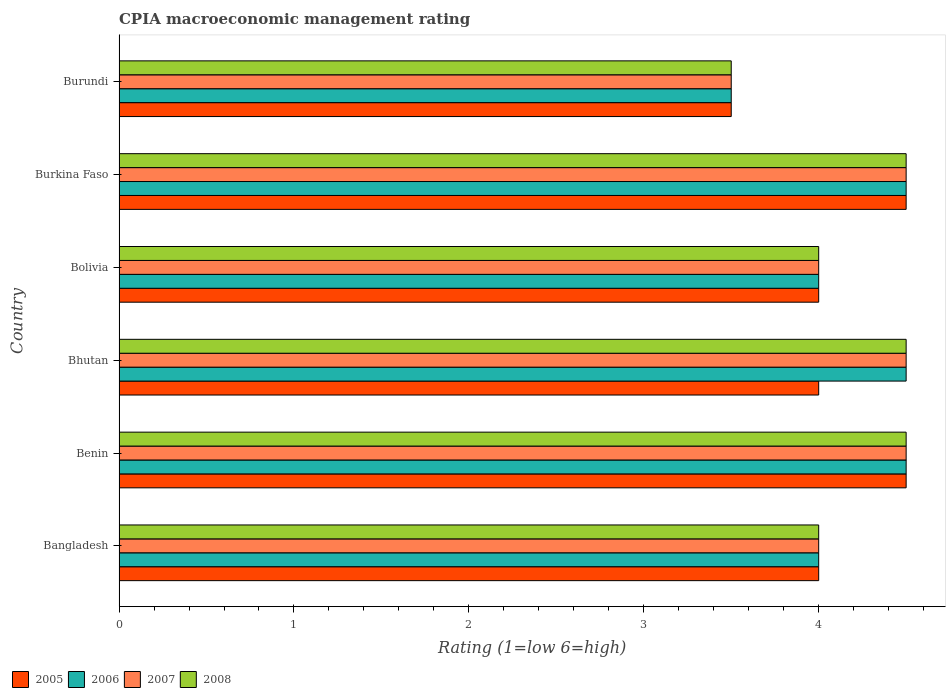How many different coloured bars are there?
Your answer should be very brief. 4. Are the number of bars per tick equal to the number of legend labels?
Keep it short and to the point. Yes. How many bars are there on the 2nd tick from the bottom?
Ensure brevity in your answer.  4. What is the label of the 4th group of bars from the top?
Your response must be concise. Bhutan. Across all countries, what is the minimum CPIA rating in 2006?
Offer a terse response. 3.5. In which country was the CPIA rating in 2005 maximum?
Your answer should be very brief. Benin. In which country was the CPIA rating in 2005 minimum?
Your answer should be very brief. Burundi. What is the difference between the CPIA rating in 2007 in Bangladesh and that in Burundi?
Make the answer very short. 0.5. What is the difference between the CPIA rating in 2007 in Bhutan and the CPIA rating in 2006 in Benin?
Offer a terse response. 0. What is the average CPIA rating in 2006 per country?
Keep it short and to the point. 4.17. In how many countries, is the CPIA rating in 2008 greater than 4 ?
Offer a very short reply. 3. What is the ratio of the CPIA rating in 2006 in Bolivia to that in Burkina Faso?
Your answer should be very brief. 0.89. Is the CPIA rating in 2005 in Bangladesh less than that in Burkina Faso?
Make the answer very short. Yes. What is the difference between the highest and the second highest CPIA rating in 2007?
Offer a terse response. 0. In how many countries, is the CPIA rating in 2006 greater than the average CPIA rating in 2006 taken over all countries?
Make the answer very short. 3. Is it the case that in every country, the sum of the CPIA rating in 2008 and CPIA rating in 2005 is greater than the sum of CPIA rating in 2006 and CPIA rating in 2007?
Keep it short and to the point. No. What does the 4th bar from the bottom in Bangladesh represents?
Provide a succinct answer. 2008. How many bars are there?
Keep it short and to the point. 24. What is the difference between two consecutive major ticks on the X-axis?
Make the answer very short. 1. Does the graph contain grids?
Offer a terse response. No. How are the legend labels stacked?
Your answer should be very brief. Horizontal. What is the title of the graph?
Make the answer very short. CPIA macroeconomic management rating. What is the Rating (1=low 6=high) of 2005 in Bangladesh?
Your response must be concise. 4. What is the Rating (1=low 6=high) in 2006 in Bangladesh?
Offer a terse response. 4. What is the Rating (1=low 6=high) in 2007 in Bangladesh?
Provide a short and direct response. 4. What is the Rating (1=low 6=high) in 2008 in Bangladesh?
Your answer should be very brief. 4. What is the Rating (1=low 6=high) in 2005 in Benin?
Make the answer very short. 4.5. What is the Rating (1=low 6=high) in 2007 in Benin?
Your answer should be very brief. 4.5. What is the Rating (1=low 6=high) of 2008 in Benin?
Provide a short and direct response. 4.5. What is the Rating (1=low 6=high) in 2006 in Bhutan?
Offer a very short reply. 4.5. What is the Rating (1=low 6=high) in 2005 in Burkina Faso?
Give a very brief answer. 4.5. What is the Rating (1=low 6=high) in 2005 in Burundi?
Make the answer very short. 3.5. What is the Rating (1=low 6=high) of 2006 in Burundi?
Your answer should be compact. 3.5. What is the Rating (1=low 6=high) in 2007 in Burundi?
Offer a terse response. 3.5. Across all countries, what is the maximum Rating (1=low 6=high) of 2008?
Your response must be concise. 4.5. Across all countries, what is the minimum Rating (1=low 6=high) of 2006?
Give a very brief answer. 3.5. Across all countries, what is the minimum Rating (1=low 6=high) in 2007?
Make the answer very short. 3.5. What is the total Rating (1=low 6=high) of 2005 in the graph?
Offer a terse response. 24.5. What is the total Rating (1=low 6=high) of 2006 in the graph?
Your answer should be very brief. 25. What is the total Rating (1=low 6=high) of 2007 in the graph?
Provide a short and direct response. 25. What is the total Rating (1=low 6=high) of 2008 in the graph?
Your answer should be compact. 25. What is the difference between the Rating (1=low 6=high) in 2005 in Bangladesh and that in Benin?
Offer a terse response. -0.5. What is the difference between the Rating (1=low 6=high) in 2006 in Bangladesh and that in Benin?
Your answer should be very brief. -0.5. What is the difference between the Rating (1=low 6=high) of 2007 in Bangladesh and that in Benin?
Give a very brief answer. -0.5. What is the difference between the Rating (1=low 6=high) in 2008 in Bangladesh and that in Benin?
Provide a short and direct response. -0.5. What is the difference between the Rating (1=low 6=high) of 2006 in Bangladesh and that in Bhutan?
Ensure brevity in your answer.  -0.5. What is the difference between the Rating (1=low 6=high) of 2007 in Bangladesh and that in Bhutan?
Your answer should be compact. -0.5. What is the difference between the Rating (1=low 6=high) of 2008 in Bangladesh and that in Bhutan?
Offer a very short reply. -0.5. What is the difference between the Rating (1=low 6=high) of 2006 in Bangladesh and that in Bolivia?
Make the answer very short. 0. What is the difference between the Rating (1=low 6=high) of 2007 in Bangladesh and that in Bolivia?
Give a very brief answer. 0. What is the difference between the Rating (1=low 6=high) of 2008 in Bangladesh and that in Bolivia?
Your answer should be very brief. 0. What is the difference between the Rating (1=low 6=high) of 2005 in Bangladesh and that in Burkina Faso?
Offer a very short reply. -0.5. What is the difference between the Rating (1=low 6=high) of 2006 in Bangladesh and that in Burkina Faso?
Offer a terse response. -0.5. What is the difference between the Rating (1=low 6=high) of 2005 in Bangladesh and that in Burundi?
Give a very brief answer. 0.5. What is the difference between the Rating (1=low 6=high) of 2007 in Bangladesh and that in Burundi?
Your response must be concise. 0.5. What is the difference between the Rating (1=low 6=high) in 2005 in Benin and that in Bhutan?
Ensure brevity in your answer.  0.5. What is the difference between the Rating (1=low 6=high) in 2006 in Benin and that in Bhutan?
Make the answer very short. 0. What is the difference between the Rating (1=low 6=high) of 2008 in Benin and that in Bhutan?
Offer a terse response. 0. What is the difference between the Rating (1=low 6=high) in 2005 in Benin and that in Bolivia?
Your response must be concise. 0.5. What is the difference between the Rating (1=low 6=high) of 2008 in Benin and that in Bolivia?
Your answer should be very brief. 0.5. What is the difference between the Rating (1=low 6=high) of 2008 in Benin and that in Burkina Faso?
Provide a short and direct response. 0. What is the difference between the Rating (1=low 6=high) of 2007 in Benin and that in Burundi?
Give a very brief answer. 1. What is the difference between the Rating (1=low 6=high) in 2008 in Benin and that in Burundi?
Make the answer very short. 1. What is the difference between the Rating (1=low 6=high) of 2008 in Bhutan and that in Bolivia?
Provide a succinct answer. 0.5. What is the difference between the Rating (1=low 6=high) in 2008 in Bhutan and that in Burkina Faso?
Offer a very short reply. 0. What is the difference between the Rating (1=low 6=high) in 2006 in Bhutan and that in Burundi?
Give a very brief answer. 1. What is the difference between the Rating (1=low 6=high) in 2008 in Bhutan and that in Burundi?
Give a very brief answer. 1. What is the difference between the Rating (1=low 6=high) of 2007 in Bolivia and that in Burundi?
Provide a short and direct response. 0.5. What is the difference between the Rating (1=low 6=high) of 2005 in Burkina Faso and that in Burundi?
Ensure brevity in your answer.  1. What is the difference between the Rating (1=low 6=high) in 2007 in Burkina Faso and that in Burundi?
Offer a terse response. 1. What is the difference between the Rating (1=low 6=high) in 2008 in Burkina Faso and that in Burundi?
Ensure brevity in your answer.  1. What is the difference between the Rating (1=low 6=high) of 2005 in Bangladesh and the Rating (1=low 6=high) of 2006 in Benin?
Provide a succinct answer. -0.5. What is the difference between the Rating (1=low 6=high) in 2005 in Bangladesh and the Rating (1=low 6=high) in 2007 in Benin?
Your answer should be compact. -0.5. What is the difference between the Rating (1=low 6=high) in 2005 in Bangladesh and the Rating (1=low 6=high) in 2008 in Benin?
Offer a terse response. -0.5. What is the difference between the Rating (1=low 6=high) in 2006 in Bangladesh and the Rating (1=low 6=high) in 2007 in Bhutan?
Provide a short and direct response. -0.5. What is the difference between the Rating (1=low 6=high) in 2006 in Bangladesh and the Rating (1=low 6=high) in 2008 in Bhutan?
Offer a very short reply. -0.5. What is the difference between the Rating (1=low 6=high) of 2007 in Bangladesh and the Rating (1=low 6=high) of 2008 in Bhutan?
Offer a terse response. -0.5. What is the difference between the Rating (1=low 6=high) of 2005 in Bangladesh and the Rating (1=low 6=high) of 2006 in Bolivia?
Provide a short and direct response. 0. What is the difference between the Rating (1=low 6=high) of 2005 in Bangladesh and the Rating (1=low 6=high) of 2007 in Bolivia?
Provide a succinct answer. 0. What is the difference between the Rating (1=low 6=high) of 2006 in Bangladesh and the Rating (1=low 6=high) of 2007 in Bolivia?
Provide a short and direct response. 0. What is the difference between the Rating (1=low 6=high) of 2005 in Bangladesh and the Rating (1=low 6=high) of 2007 in Burkina Faso?
Ensure brevity in your answer.  -0.5. What is the difference between the Rating (1=low 6=high) of 2006 in Bangladesh and the Rating (1=low 6=high) of 2007 in Burkina Faso?
Your answer should be very brief. -0.5. What is the difference between the Rating (1=low 6=high) in 2007 in Bangladesh and the Rating (1=low 6=high) in 2008 in Burkina Faso?
Your response must be concise. -0.5. What is the difference between the Rating (1=low 6=high) of 2005 in Bangladesh and the Rating (1=low 6=high) of 2006 in Burundi?
Your answer should be compact. 0.5. What is the difference between the Rating (1=low 6=high) in 2005 in Bangladesh and the Rating (1=low 6=high) in 2008 in Burundi?
Ensure brevity in your answer.  0.5. What is the difference between the Rating (1=low 6=high) of 2007 in Bangladesh and the Rating (1=low 6=high) of 2008 in Burundi?
Offer a terse response. 0.5. What is the difference between the Rating (1=low 6=high) of 2005 in Benin and the Rating (1=low 6=high) of 2007 in Bhutan?
Provide a succinct answer. 0. What is the difference between the Rating (1=low 6=high) in 2006 in Benin and the Rating (1=low 6=high) in 2008 in Bhutan?
Give a very brief answer. 0. What is the difference between the Rating (1=low 6=high) in 2006 in Benin and the Rating (1=low 6=high) in 2007 in Bolivia?
Your answer should be compact. 0.5. What is the difference between the Rating (1=low 6=high) in 2006 in Benin and the Rating (1=low 6=high) in 2008 in Bolivia?
Your answer should be very brief. 0.5. What is the difference between the Rating (1=low 6=high) of 2007 in Benin and the Rating (1=low 6=high) of 2008 in Bolivia?
Ensure brevity in your answer.  0.5. What is the difference between the Rating (1=low 6=high) of 2005 in Benin and the Rating (1=low 6=high) of 2006 in Burkina Faso?
Offer a terse response. 0. What is the difference between the Rating (1=low 6=high) of 2005 in Benin and the Rating (1=low 6=high) of 2007 in Burkina Faso?
Offer a terse response. 0. What is the difference between the Rating (1=low 6=high) of 2006 in Benin and the Rating (1=low 6=high) of 2007 in Burkina Faso?
Your response must be concise. 0. What is the difference between the Rating (1=low 6=high) of 2006 in Benin and the Rating (1=low 6=high) of 2008 in Burkina Faso?
Ensure brevity in your answer.  0. What is the difference between the Rating (1=low 6=high) of 2005 in Benin and the Rating (1=low 6=high) of 2006 in Burundi?
Your response must be concise. 1. What is the difference between the Rating (1=low 6=high) in 2005 in Benin and the Rating (1=low 6=high) in 2007 in Burundi?
Ensure brevity in your answer.  1. What is the difference between the Rating (1=low 6=high) in 2005 in Benin and the Rating (1=low 6=high) in 2008 in Burundi?
Provide a short and direct response. 1. What is the difference between the Rating (1=low 6=high) of 2006 in Benin and the Rating (1=low 6=high) of 2007 in Burundi?
Your answer should be very brief. 1. What is the difference between the Rating (1=low 6=high) in 2007 in Benin and the Rating (1=low 6=high) in 2008 in Burundi?
Provide a succinct answer. 1. What is the difference between the Rating (1=low 6=high) in 2005 in Bhutan and the Rating (1=low 6=high) in 2006 in Bolivia?
Make the answer very short. 0. What is the difference between the Rating (1=low 6=high) of 2005 in Bhutan and the Rating (1=low 6=high) of 2007 in Bolivia?
Give a very brief answer. 0. What is the difference between the Rating (1=low 6=high) of 2006 in Bhutan and the Rating (1=low 6=high) of 2007 in Bolivia?
Your response must be concise. 0.5. What is the difference between the Rating (1=low 6=high) of 2005 in Bhutan and the Rating (1=low 6=high) of 2007 in Burkina Faso?
Your answer should be very brief. -0.5. What is the difference between the Rating (1=low 6=high) of 2006 in Bhutan and the Rating (1=low 6=high) of 2007 in Burkina Faso?
Provide a succinct answer. 0. What is the difference between the Rating (1=low 6=high) in 2006 in Bhutan and the Rating (1=low 6=high) in 2008 in Burkina Faso?
Give a very brief answer. 0. What is the difference between the Rating (1=low 6=high) of 2005 in Bhutan and the Rating (1=low 6=high) of 2007 in Burundi?
Offer a terse response. 0.5. What is the difference between the Rating (1=low 6=high) of 2005 in Bhutan and the Rating (1=low 6=high) of 2008 in Burundi?
Make the answer very short. 0.5. What is the difference between the Rating (1=low 6=high) of 2006 in Bhutan and the Rating (1=low 6=high) of 2007 in Burundi?
Ensure brevity in your answer.  1. What is the difference between the Rating (1=low 6=high) in 2007 in Bhutan and the Rating (1=low 6=high) in 2008 in Burundi?
Ensure brevity in your answer.  1. What is the difference between the Rating (1=low 6=high) of 2005 in Bolivia and the Rating (1=low 6=high) of 2006 in Burkina Faso?
Keep it short and to the point. -0.5. What is the difference between the Rating (1=low 6=high) of 2005 in Bolivia and the Rating (1=low 6=high) of 2008 in Burkina Faso?
Offer a very short reply. -0.5. What is the difference between the Rating (1=low 6=high) of 2006 in Bolivia and the Rating (1=low 6=high) of 2007 in Burkina Faso?
Offer a very short reply. -0.5. What is the difference between the Rating (1=low 6=high) of 2006 in Bolivia and the Rating (1=low 6=high) of 2008 in Burkina Faso?
Your answer should be very brief. -0.5. What is the difference between the Rating (1=low 6=high) in 2005 in Bolivia and the Rating (1=low 6=high) in 2006 in Burundi?
Provide a short and direct response. 0.5. What is the difference between the Rating (1=low 6=high) of 2005 in Bolivia and the Rating (1=low 6=high) of 2007 in Burundi?
Your answer should be very brief. 0.5. What is the difference between the Rating (1=low 6=high) in 2005 in Bolivia and the Rating (1=low 6=high) in 2008 in Burundi?
Provide a short and direct response. 0.5. What is the difference between the Rating (1=low 6=high) in 2006 in Bolivia and the Rating (1=low 6=high) in 2007 in Burundi?
Give a very brief answer. 0.5. What is the difference between the Rating (1=low 6=high) of 2007 in Bolivia and the Rating (1=low 6=high) of 2008 in Burundi?
Give a very brief answer. 0.5. What is the difference between the Rating (1=low 6=high) in 2005 in Burkina Faso and the Rating (1=low 6=high) in 2007 in Burundi?
Provide a short and direct response. 1. What is the difference between the Rating (1=low 6=high) of 2006 in Burkina Faso and the Rating (1=low 6=high) of 2007 in Burundi?
Keep it short and to the point. 1. What is the difference between the Rating (1=low 6=high) of 2006 in Burkina Faso and the Rating (1=low 6=high) of 2008 in Burundi?
Offer a terse response. 1. What is the difference between the Rating (1=low 6=high) in 2007 in Burkina Faso and the Rating (1=low 6=high) in 2008 in Burundi?
Give a very brief answer. 1. What is the average Rating (1=low 6=high) in 2005 per country?
Offer a terse response. 4.08. What is the average Rating (1=low 6=high) of 2006 per country?
Your response must be concise. 4.17. What is the average Rating (1=low 6=high) of 2007 per country?
Offer a very short reply. 4.17. What is the average Rating (1=low 6=high) of 2008 per country?
Keep it short and to the point. 4.17. What is the difference between the Rating (1=low 6=high) of 2006 and Rating (1=low 6=high) of 2007 in Bangladesh?
Ensure brevity in your answer.  0. What is the difference between the Rating (1=low 6=high) in 2007 and Rating (1=low 6=high) in 2008 in Bangladesh?
Ensure brevity in your answer.  0. What is the difference between the Rating (1=low 6=high) of 2005 and Rating (1=low 6=high) of 2008 in Benin?
Offer a terse response. 0. What is the difference between the Rating (1=low 6=high) in 2006 and Rating (1=low 6=high) in 2008 in Bhutan?
Provide a short and direct response. 0. What is the difference between the Rating (1=low 6=high) in 2005 and Rating (1=low 6=high) in 2006 in Bolivia?
Give a very brief answer. 0. What is the difference between the Rating (1=low 6=high) of 2005 and Rating (1=low 6=high) of 2007 in Bolivia?
Ensure brevity in your answer.  0. What is the difference between the Rating (1=low 6=high) of 2005 and Rating (1=low 6=high) of 2008 in Bolivia?
Ensure brevity in your answer.  0. What is the difference between the Rating (1=low 6=high) in 2007 and Rating (1=low 6=high) in 2008 in Bolivia?
Your response must be concise. 0. What is the difference between the Rating (1=low 6=high) of 2005 and Rating (1=low 6=high) of 2006 in Burkina Faso?
Ensure brevity in your answer.  0. What is the difference between the Rating (1=low 6=high) in 2005 and Rating (1=low 6=high) in 2008 in Burkina Faso?
Provide a short and direct response. 0. What is the difference between the Rating (1=low 6=high) of 2006 and Rating (1=low 6=high) of 2007 in Burkina Faso?
Your response must be concise. 0. What is the difference between the Rating (1=low 6=high) of 2007 and Rating (1=low 6=high) of 2008 in Burkina Faso?
Make the answer very short. 0. What is the difference between the Rating (1=low 6=high) in 2005 and Rating (1=low 6=high) in 2007 in Burundi?
Make the answer very short. 0. What is the difference between the Rating (1=low 6=high) of 2005 and Rating (1=low 6=high) of 2008 in Burundi?
Offer a very short reply. 0. What is the difference between the Rating (1=low 6=high) of 2006 and Rating (1=low 6=high) of 2008 in Burundi?
Your response must be concise. 0. What is the ratio of the Rating (1=low 6=high) of 2006 in Bangladesh to that in Benin?
Ensure brevity in your answer.  0.89. What is the ratio of the Rating (1=low 6=high) in 2005 in Bangladesh to that in Bhutan?
Provide a succinct answer. 1. What is the ratio of the Rating (1=low 6=high) of 2006 in Bangladesh to that in Bhutan?
Provide a short and direct response. 0.89. What is the ratio of the Rating (1=low 6=high) of 2007 in Bangladesh to that in Bhutan?
Keep it short and to the point. 0.89. What is the ratio of the Rating (1=low 6=high) in 2008 in Bangladesh to that in Bhutan?
Offer a very short reply. 0.89. What is the ratio of the Rating (1=low 6=high) of 2006 in Bangladesh to that in Bolivia?
Your answer should be compact. 1. What is the ratio of the Rating (1=low 6=high) of 2007 in Bangladesh to that in Bolivia?
Make the answer very short. 1. What is the ratio of the Rating (1=low 6=high) of 2005 in Bangladesh to that in Burkina Faso?
Your answer should be compact. 0.89. What is the ratio of the Rating (1=low 6=high) of 2005 in Bangladesh to that in Burundi?
Give a very brief answer. 1.14. What is the ratio of the Rating (1=low 6=high) of 2006 in Benin to that in Bhutan?
Your response must be concise. 1. What is the ratio of the Rating (1=low 6=high) in 2008 in Benin to that in Bhutan?
Your answer should be very brief. 1. What is the ratio of the Rating (1=low 6=high) of 2006 in Benin to that in Bolivia?
Your answer should be very brief. 1.12. What is the ratio of the Rating (1=low 6=high) in 2007 in Benin to that in Burkina Faso?
Provide a succinct answer. 1. What is the ratio of the Rating (1=low 6=high) in 2006 in Benin to that in Burundi?
Keep it short and to the point. 1.29. What is the ratio of the Rating (1=low 6=high) in 2008 in Benin to that in Burundi?
Make the answer very short. 1.29. What is the ratio of the Rating (1=low 6=high) of 2005 in Bhutan to that in Bolivia?
Offer a very short reply. 1. What is the ratio of the Rating (1=low 6=high) of 2006 in Bhutan to that in Bolivia?
Offer a terse response. 1.12. What is the ratio of the Rating (1=low 6=high) in 2007 in Bhutan to that in Bolivia?
Ensure brevity in your answer.  1.12. What is the ratio of the Rating (1=low 6=high) of 2008 in Bhutan to that in Bolivia?
Keep it short and to the point. 1.12. What is the ratio of the Rating (1=low 6=high) of 2007 in Bhutan to that in Burkina Faso?
Your response must be concise. 1. What is the ratio of the Rating (1=low 6=high) of 2008 in Bhutan to that in Burkina Faso?
Make the answer very short. 1. What is the ratio of the Rating (1=low 6=high) of 2005 in Bolivia to that in Burkina Faso?
Offer a terse response. 0.89. What is the ratio of the Rating (1=low 6=high) of 2006 in Bolivia to that in Burkina Faso?
Ensure brevity in your answer.  0.89. What is the ratio of the Rating (1=low 6=high) in 2007 in Bolivia to that in Burkina Faso?
Give a very brief answer. 0.89. What is the ratio of the Rating (1=low 6=high) in 2008 in Bolivia to that in Burkina Faso?
Provide a short and direct response. 0.89. What is the ratio of the Rating (1=low 6=high) in 2006 in Burkina Faso to that in Burundi?
Your answer should be compact. 1.29. What is the difference between the highest and the second highest Rating (1=low 6=high) of 2005?
Offer a very short reply. 0. What is the difference between the highest and the second highest Rating (1=low 6=high) of 2006?
Make the answer very short. 0. What is the difference between the highest and the lowest Rating (1=low 6=high) of 2005?
Ensure brevity in your answer.  1. What is the difference between the highest and the lowest Rating (1=low 6=high) in 2006?
Your answer should be very brief. 1. What is the difference between the highest and the lowest Rating (1=low 6=high) in 2007?
Your answer should be very brief. 1. What is the difference between the highest and the lowest Rating (1=low 6=high) of 2008?
Keep it short and to the point. 1. 